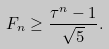Convert formula to latex. <formula><loc_0><loc_0><loc_500><loc_500>F _ { n } \geq \frac { \tau ^ { n } - 1 } { \sqrt { 5 } } .</formula> 